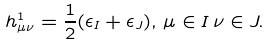Convert formula to latex. <formula><loc_0><loc_0><loc_500><loc_500>h ^ { 1 } _ { \mu \nu } = \frac { 1 } { 2 } ( \epsilon _ { I } + \epsilon _ { J } ) , \, \mu \in I \, \nu \in J .</formula> 